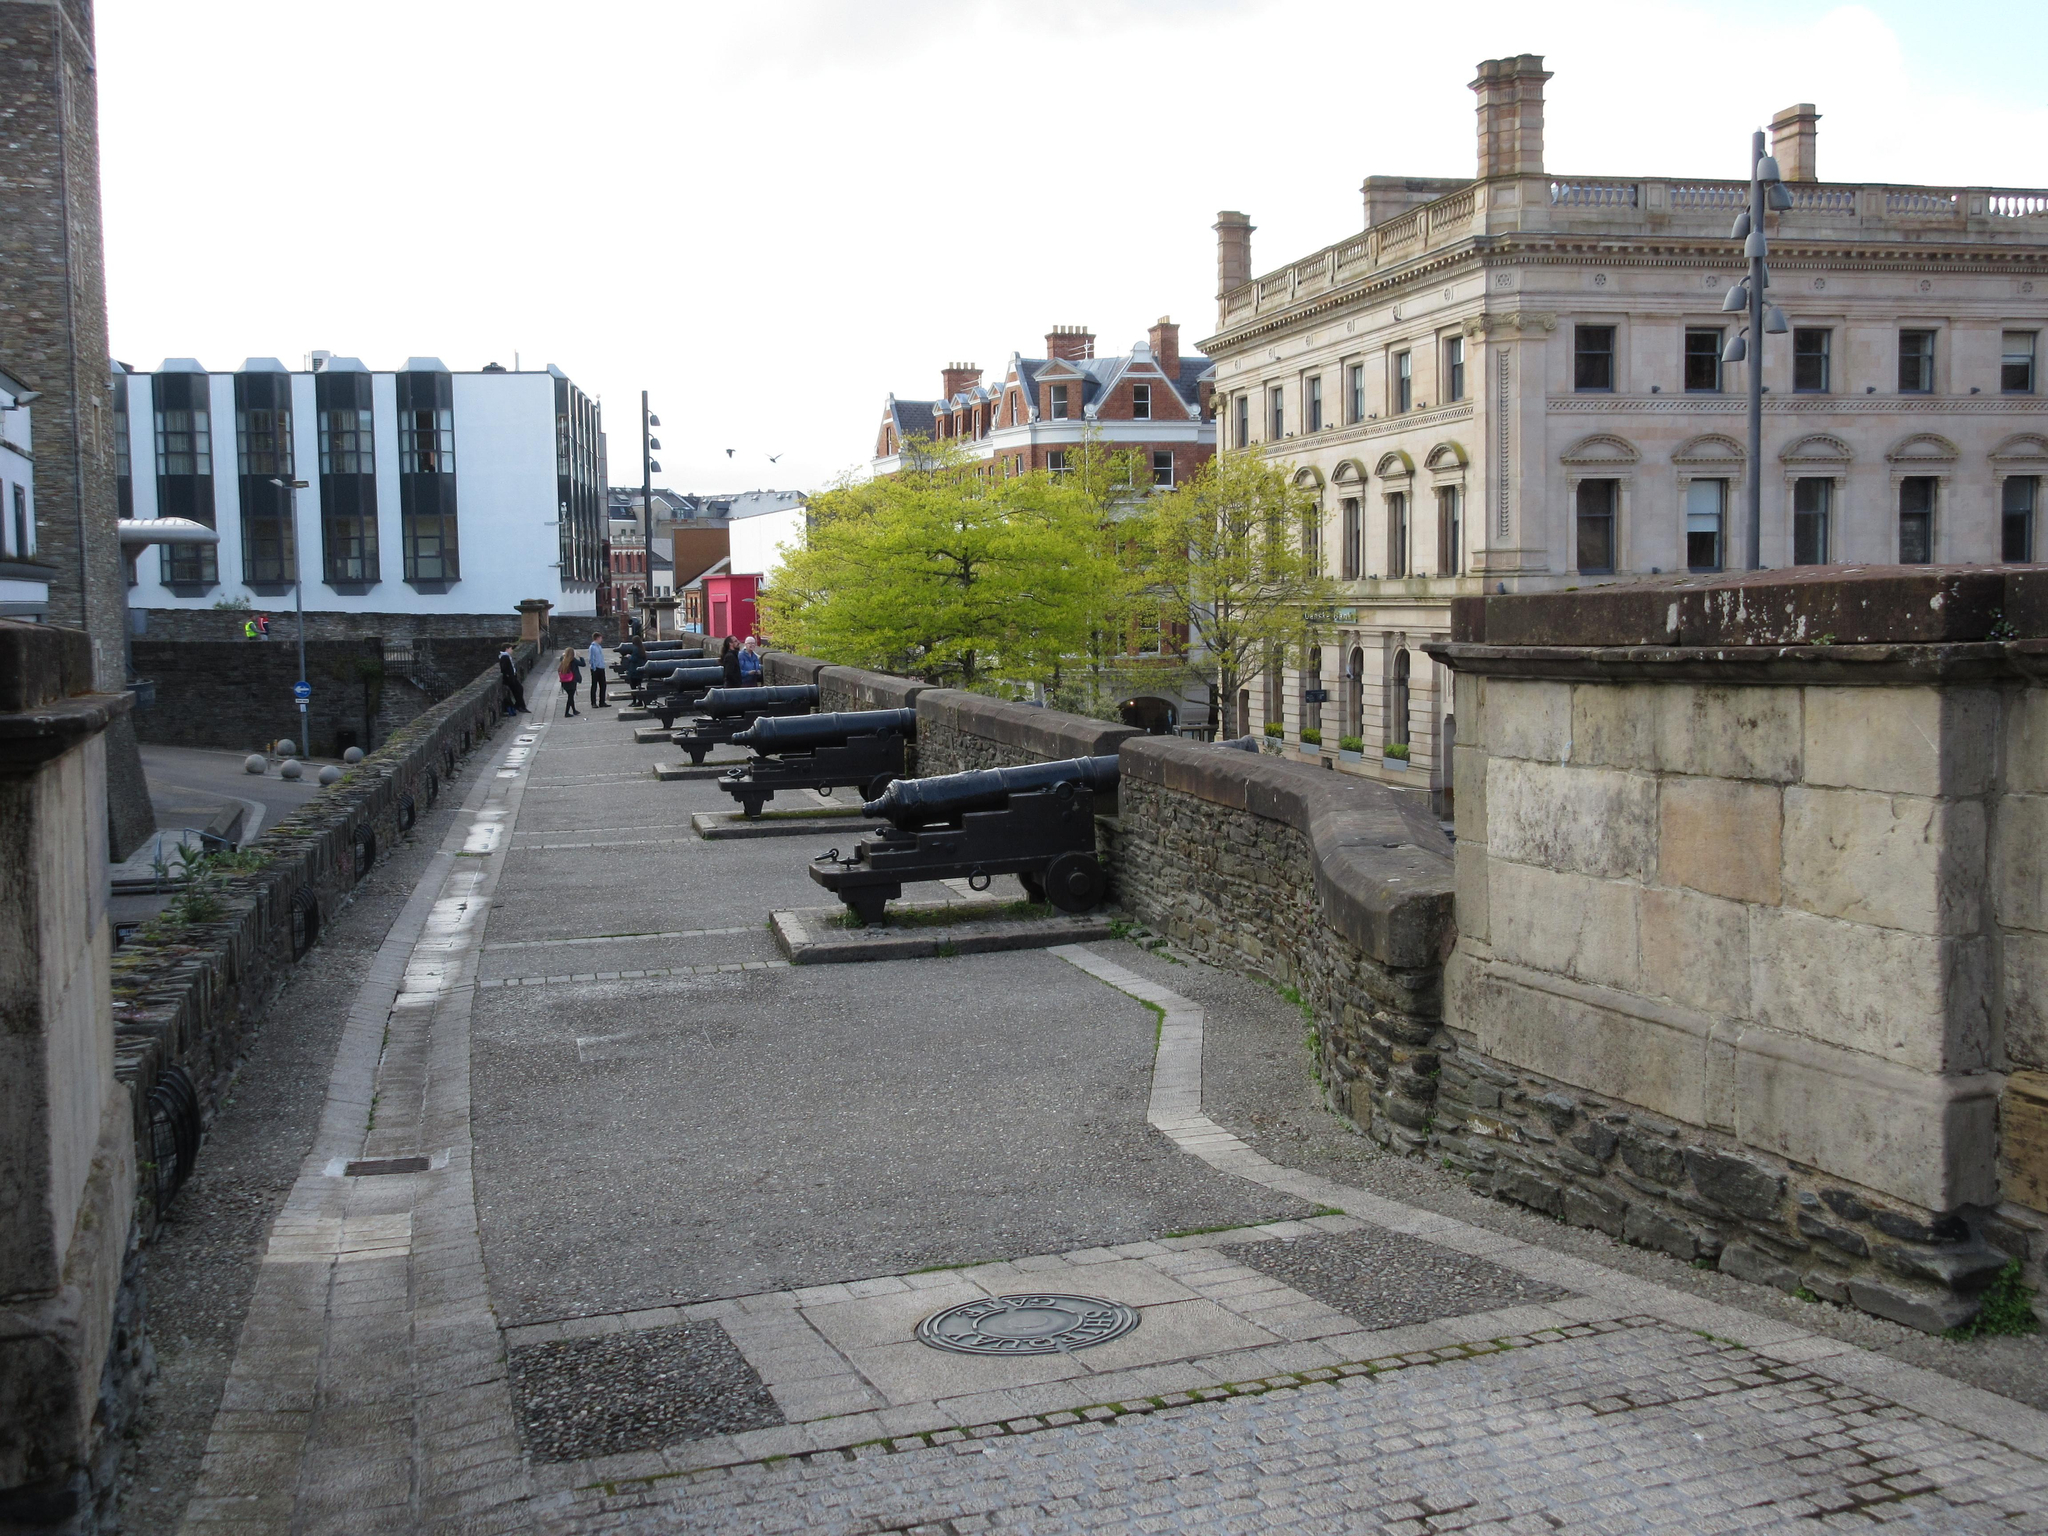What are the two persons in the image doing? The two persons in the image are walking on the road. What can be seen on the right side of the image? There are buildings and trees on the right side of the image. What can be seen on the left side of the image? There are buildings and trees on the left side of the image. What is visible in the background of the image? The sky is visible in the background of the image. What letter is the person on the left side of the image holding? There is no person holding a letter in the image; the two persons are walking on the road. What is the teaching method used by the trees on the right side of the image? There is no teaching method associated with the trees in the image; they are simply part of the natural environment. 